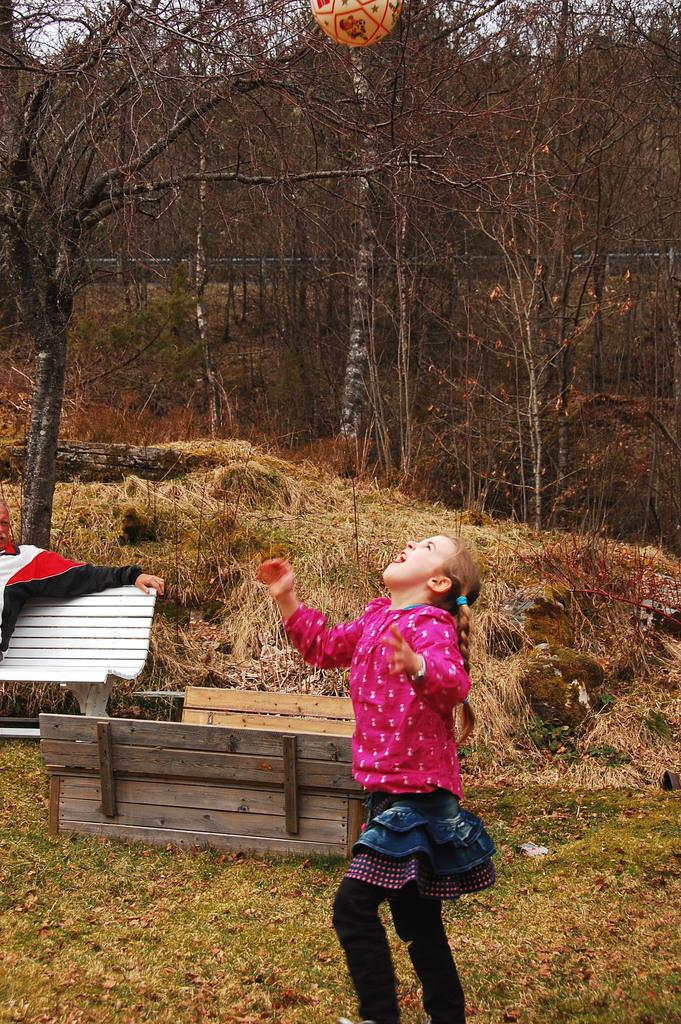What is the main subject of the image? There is a girl standing in the image. What is the girl doing in the image? The girl is looking up. What can be seen in the background of the image? There is a bench and a tree in the background of the image, as well as the sky. What type of current can be seen flowing through the tree in the image? There is no current flowing through the tree in the image, as it is a static image and not a video or animation. Can you see a cat sitting on the bench in the image? There is no cat present in the image; it only features a girl, a bench, a tree, and the sky. 